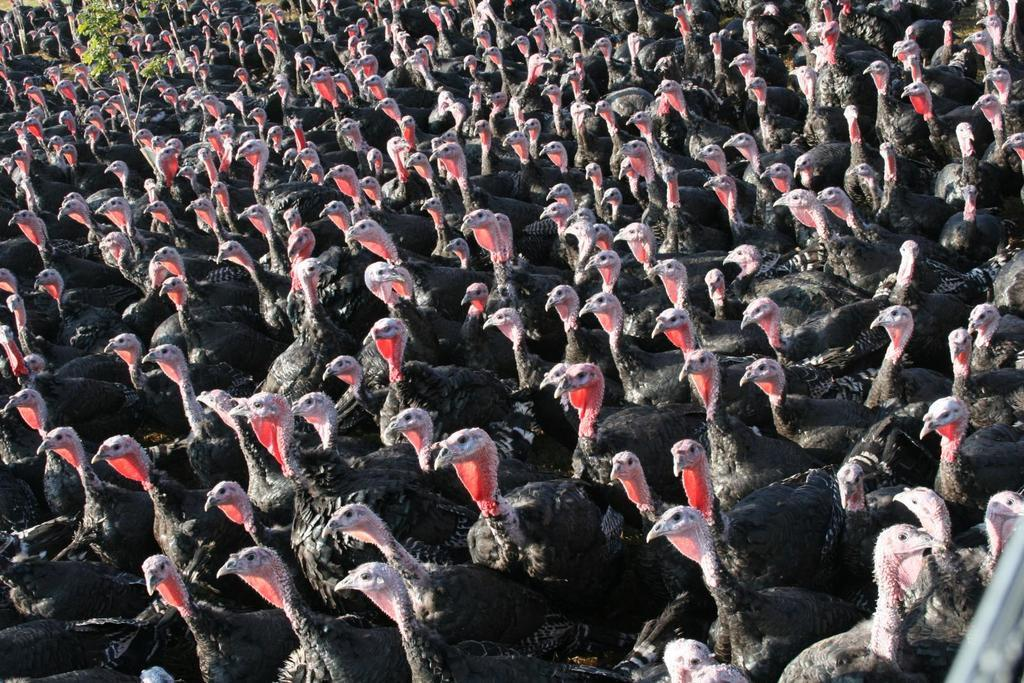What animals are present in the image? There are turkeys in the image. Can you describe any other elements in the image besides the turkeys? Yes, there is a plant in the top left corner of the image. What type of cloud is present in the image? There is no cloud present in the image; it only features turkeys and a plant. What role does the minister play in the image? There is no minister present in the image. 